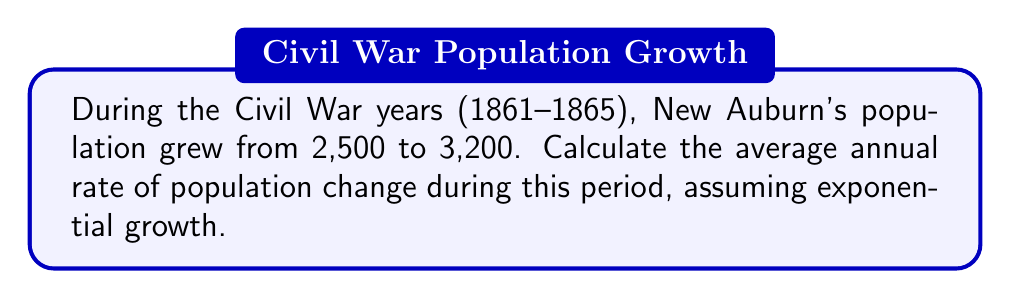Can you solve this math problem? To solve this problem, we'll use the exponential growth formula:

$$P(t) = P_0 e^{rt}$$

Where:
$P(t)$ is the population at time $t$
$P_0$ is the initial population
$r$ is the growth rate
$t$ is the time period

We know:
$P_0 = 2,500$ (population in 1861)
$P(t) = 3,200$ (population in 1865)
$t = 4$ years

Let's substitute these values into the formula:

$$3,200 = 2,500 e^{4r}$$

Now, we'll solve for $r$:

1) Divide both sides by 2,500:
   $$\frac{3,200}{2,500} = e^{4r}$$

2) Take the natural logarithm of both sides:
   $$\ln(\frac{3,200}{2,500}) = \ln(e^{4r})$$

3) Simplify the right side using the properties of logarithms:
   $$\ln(\frac{3,200}{2,500}) = 4r$$

4) Solve for $r$:
   $$r = \frac{\ln(\frac{3,200}{2,500})}{4}$$

5) Calculate the value:
   $$r = \frac{\ln(1.28)}{4} \approx 0.0617$$

6) Convert to a percentage:
   $$r \approx 6.17\%$$

Therefore, the average annual rate of population change in New Auburn during the Civil War years was approximately 6.17%.
Answer: $6.17\%$ per year 